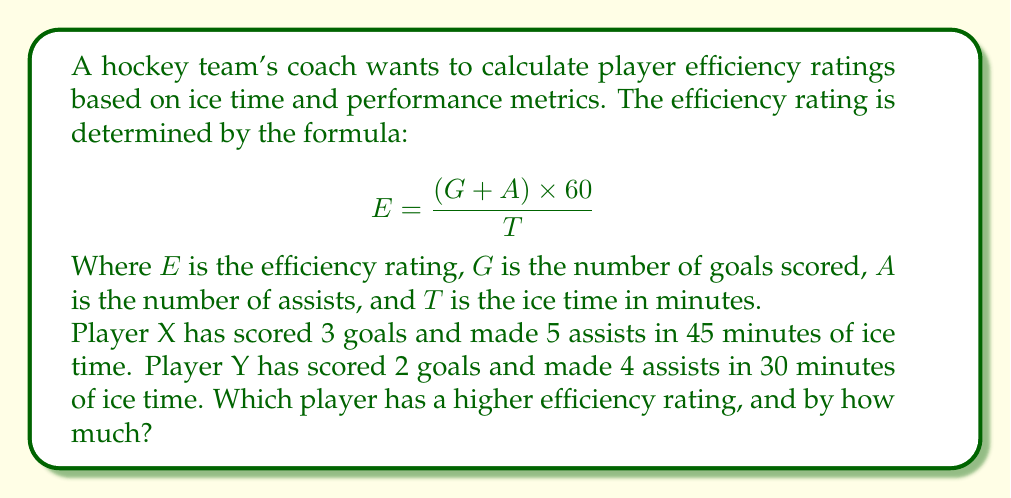Can you answer this question? Let's calculate the efficiency ratings for both players:

For Player X:
$G_X = 3$, $A_X = 5$, $T_X = 45$

$$ E_X = \frac{(3 + 5) \times 60}{45} = \frac{8 \times 60}{45} = \frac{480}{45} = 10.67 $$

For Player Y:
$G_Y = 2$, $A_Y = 4$, $T_Y = 30$

$$ E_Y = \frac{(2 + 4) \times 60}{30} = \frac{6 \times 60}{30} = \frac{360}{30} = 12 $$

To find the difference, we subtract the lower rating from the higher rating:

$$ 12 - 10.67 = 1.33 $$

Therefore, Player Y has a higher efficiency rating, and the difference is 1.33.
Answer: Player Y; 1.33 